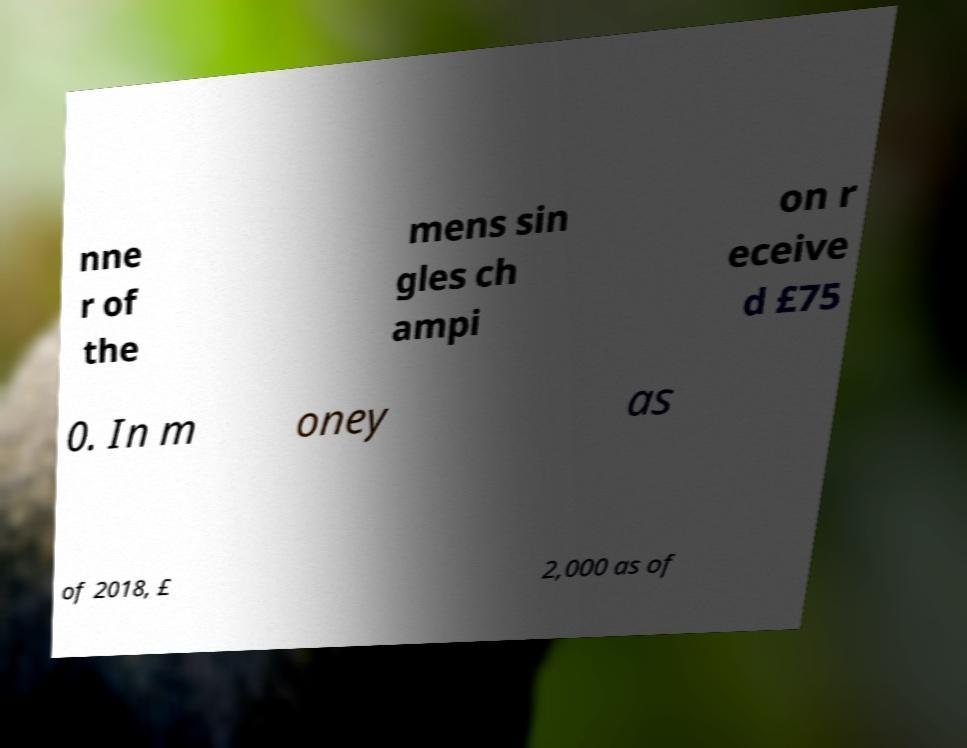Could you extract and type out the text from this image? nne r of the mens sin gles ch ampi on r eceive d £75 0. In m oney as of 2018, £ 2,000 as of 